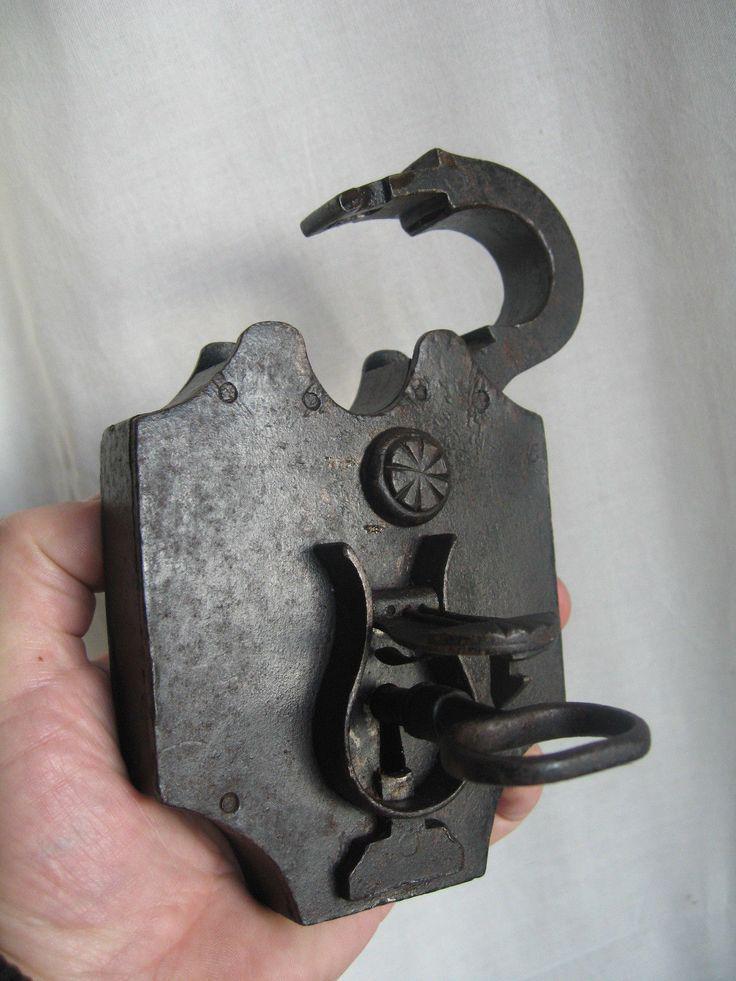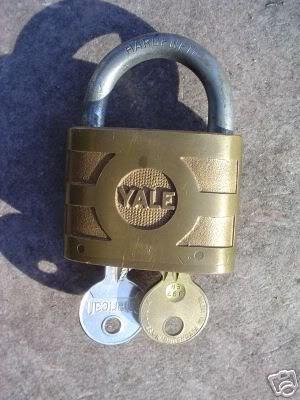The first image is the image on the left, the second image is the image on the right. For the images shown, is this caption "The right image has at least two keys." true? Answer yes or no. Yes. 